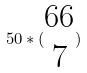Convert formula to latex. <formula><loc_0><loc_0><loc_500><loc_500>5 0 * ( \begin{matrix} 6 6 \\ 7 \end{matrix} )</formula> 